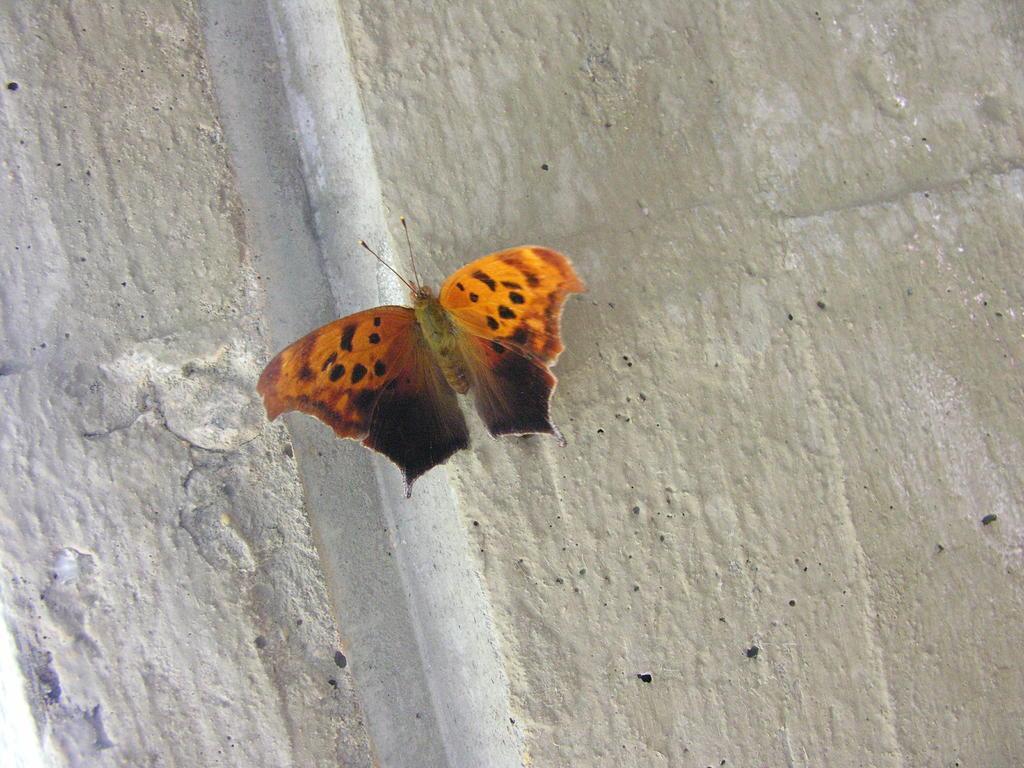Describe this image in one or two sentences. In this picture I can observe a butterfly. This butterfly is in black and orange colors. The butterfly is on the wall. 